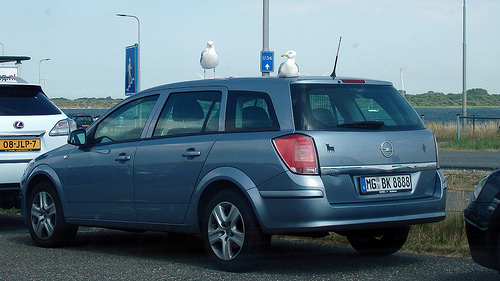<image>
Can you confirm if the water body is behind the car? No. The water body is not behind the car. From this viewpoint, the water body appears to be positioned elsewhere in the scene. Is the bird on the road? No. The bird is not positioned on the road. They may be near each other, but the bird is not supported by or resting on top of the road. Is there a bird on the white car? No. The bird is not positioned on the white car. They may be near each other, but the bird is not supported by or resting on top of the white car. 